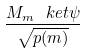<formula> <loc_0><loc_0><loc_500><loc_500>\frac { M _ { m } \ k e t { \psi } } { \sqrt { p ( m ) } }</formula> 